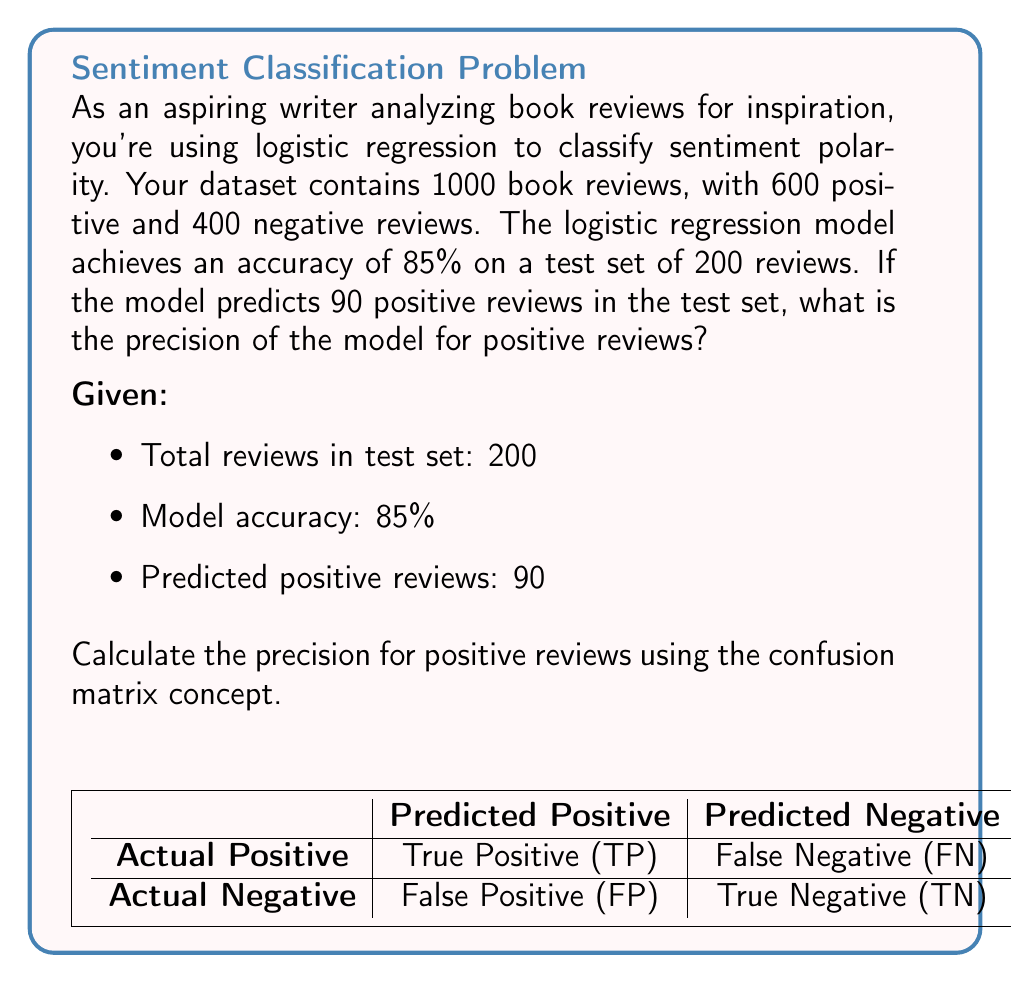Give your solution to this math problem. Let's approach this step-by-step:

1) First, we need to understand what precision means:
   Precision = $\frac{\text{True Positives}}{\text{True Positives + False Positives}}$

2) We know the model's accuracy is 85%, which means it correctly classified 85% of 200 reviews:
   Correctly classified reviews = $200 * 0.85 = 170$

3) The model predicted 90 positive reviews. Out of these, some are correct (true positives) and some are incorrect (false positives).

4) We can set up a confusion matrix:

   $$\begin{array}{c|cc}
    & \text{Actual Positive} & \text{Actual Negative} \\
   \hline
   \text{Predicted Positive} & \text{TP} & \text{FP} \\
   \text{Predicted Negative} & \text{FN} & \text{TN}
   \end{array}$$

   Where TP + FP + FN + TN = 200, and TP + FP = 90

5) We also know that TP + TN = 170 (correctly classified)

6) From steps 4 and 5, we can deduce:
   FP + FN = 200 - 170 = 30

7) Now we have two equations:
   TP + FP = 90
   FP + FN = 30

8) Subtracting the second equation from the first:
   TP - FN = 60

9) We know that TP + FN + 60 = 170 (total correct classifications)
   So, TP + FN = 110

10) Solving the system of equations:
    TP - FN = 60
    TP + FN = 110
    
    2TP = 170
    TP = 85

11) Now we can calculate precision:
    Precision = $\frac{\text{TP}}{\text{TP + FP}} = \frac{85}{90} = \frac{17}{18} \approx 0.9444$
Answer: $\frac{17}{18}$ or approximately 0.9444 